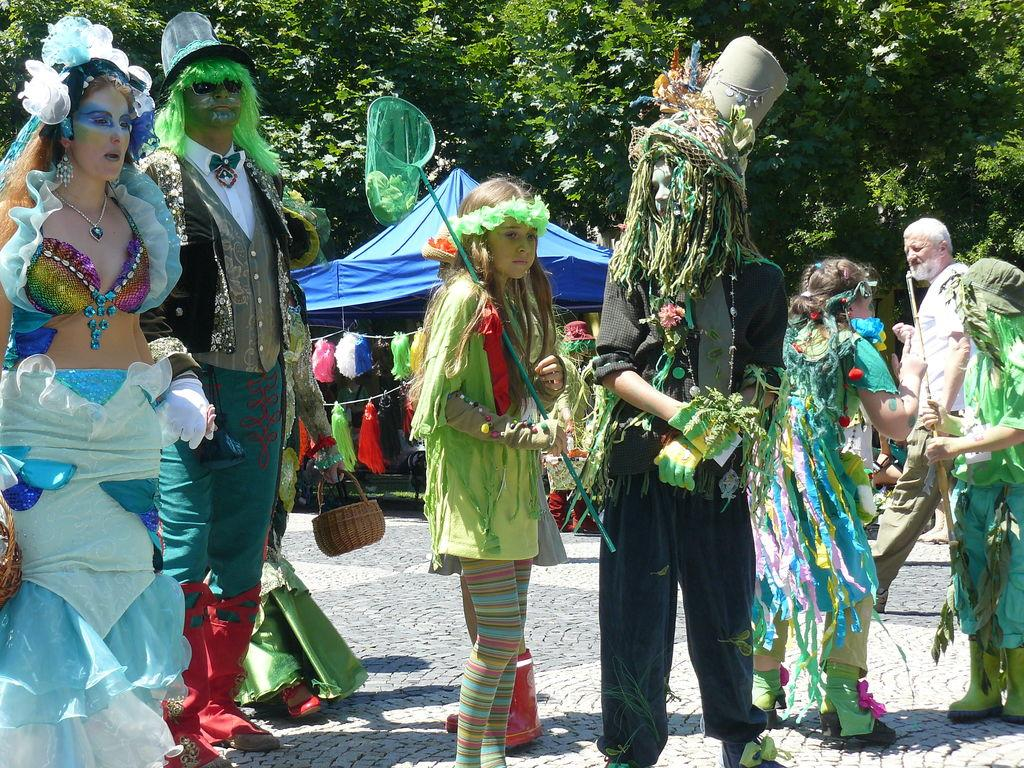What is the main subject of the image? The main subject of the image is a group of people in the foreground. What are the people doing in the image? The people are standing on the floor. What are the people wearing in the image? The people are wearing costumes. What can be seen in the background of the image? There are trees and tents in the background of the image. Can you describe the lighting conditions in the image? The image was likely taken during the day, as there is sufficient light to see the details clearly. What is the name of the mailbox located near the tents in the image? There is no mailbox present in the image. How many arrows are visible in the quiver of the person on the left side of the image? There is no quiver or person with a quiver present in the image. 